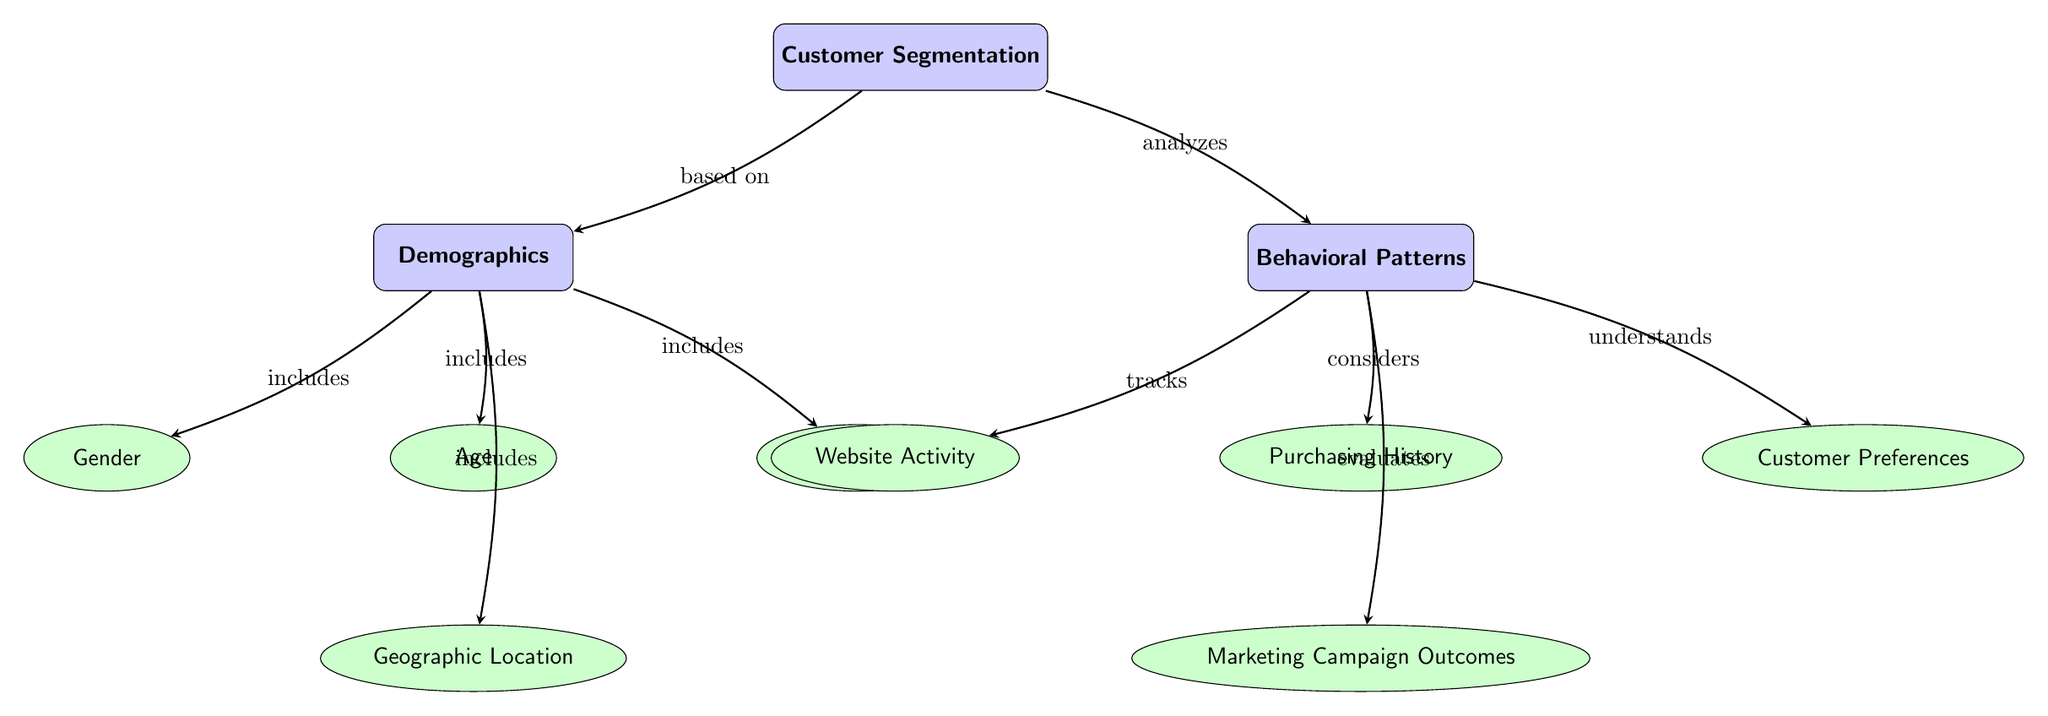What is the main category of this diagram? The main category, represented at the top of the diagram, is "Customer Segmentation." This is the title and central theme of the information presented in the diagram.
Answer: Customer Segmentation How many sub-categories are under Demographics? There are four sub-categories listed under Demographics: Age, Gender, Income Level, and Geographic Location. Counting these nodes gives us a total of four.
Answer: 4 What type of relationship connects Customer Segmentation and Demographics? The relationship is indicated by the arrow labeled "based on," showing that Demographics is a basis for Customer Segmentation. This means that customer segmentation takes into account demographic factors.
Answer: based on What factors are included in Behavioral Patterns? The Behavioral Patterns category includes Purchasing History, Website Activity, Customer Preferences, and Marketing Campaign Outcomes. These factors are explicitly listed as sub-nodes under Behavioral Patterns.
Answer: Purchasing History, Website Activity, Customer Preferences, Marketing Campaign Outcomes Which demographic sub-category is located directly below Age? The sub-category located directly below Age in the diagram is Geographic Location. The arrangement in the diagram illustrates the hierarchy and relationships among demographic factors.
Answer: Geographic Location What is the connection type between Behavioral Patterns and Website Activity? The connection type is labeled as "tracks," indicating that Website Activity is a component of Behavioral Patterns that is actively monitored or analyzed. This shows a specific relationship focusing on dynamic user engagement.
Answer: tracks How many edges are there in total in this diagram? There are a total of eight edges connecting various nodes throughout the diagram. By counting each arrow that connects the nodes, we arrive at this total.
Answer: 8 Which sub-category is related to the term "analyzes"? The sub-category related to the term "analyzes" is Behavioral Patterns, indicated by the arrow labeled "analyzes" connecting Customer Segmentation to Behavioral Patterns.
Answer: Behavioral Patterns What is the purpose of customer segmentation as indicated in this diagram? The purpose of customer segmentation, as conveyed in the diagram, is to categorize customers based on various demographic and behavioral characteristics, which enhances targeted marketing strategies.
Answer: categorize customers 